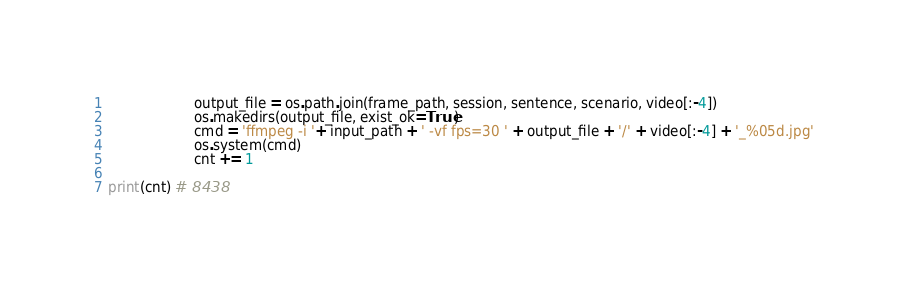<code> <loc_0><loc_0><loc_500><loc_500><_Python_>					output_file = os.path.join(frame_path, session, sentence, scenario, video[:-4])
					os.makedirs(output_file, exist_ok=True)
					cmd = 'ffmpeg -i '+ input_path + ' -vf fps=30 ' + output_file + '/' + video[:-4] + '_%05d.jpg'
					os.system(cmd)
					cnt += 1

print(cnt) # 8438
</code> 